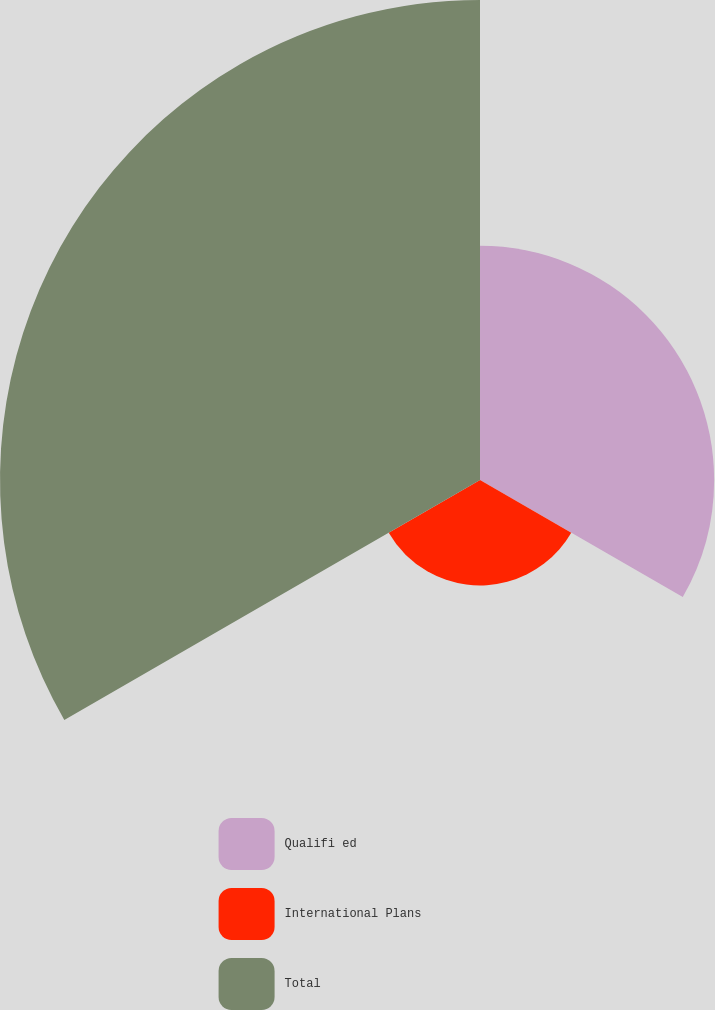Convert chart to OTSL. <chart><loc_0><loc_0><loc_500><loc_500><pie_chart><fcel>Qualifi ed<fcel>International Plans<fcel>Total<nl><fcel>28.57%<fcel>12.86%<fcel>58.57%<nl></chart> 